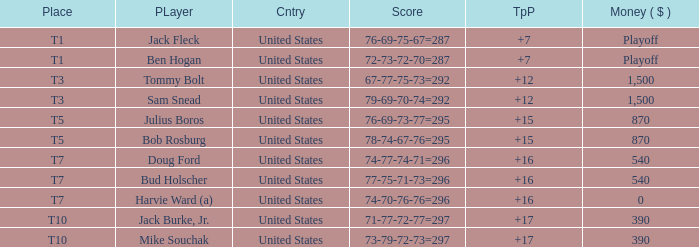Which money has player Jack Fleck with t1 place? Playoff. 